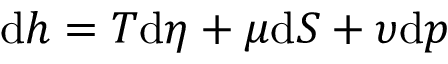Convert formula to latex. <formula><loc_0><loc_0><loc_500><loc_500>d h = T d \eta + \mu d S + \upsilon d p</formula> 